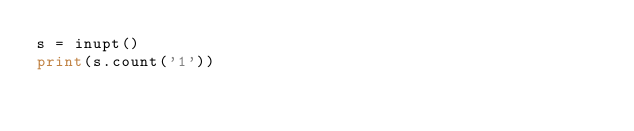<code> <loc_0><loc_0><loc_500><loc_500><_Python_>s = inupt()
print(s.count('1'))</code> 